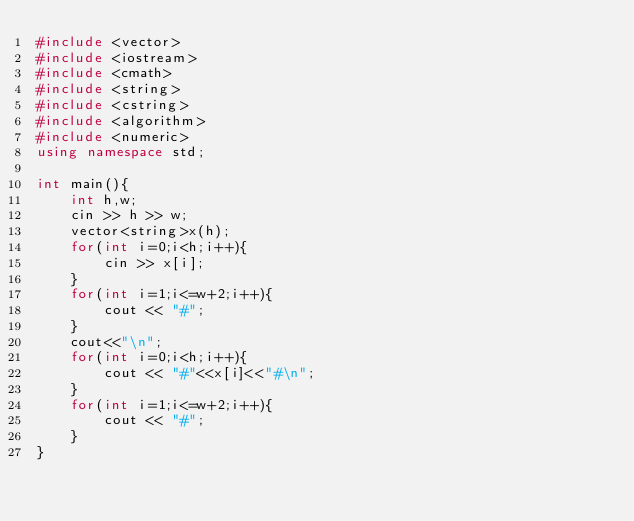<code> <loc_0><loc_0><loc_500><loc_500><_C++_>#include <vector>
#include <iostream>
#include <cmath>
#include <string>
#include <cstring>
#include <algorithm>
#include <numeric>
using namespace std;

int main(){
    int h,w;
    cin >> h >> w;
    vector<string>x(h);
    for(int i=0;i<h;i++){
        cin >> x[i];
    }
    for(int i=1;i<=w+2;i++){
        cout << "#";
    }
    cout<<"\n";
    for(int i=0;i<h;i++){
        cout << "#"<<x[i]<<"#\n";
    }
    for(int i=1;i<=w+2;i++){
        cout << "#";
    }
}</code> 